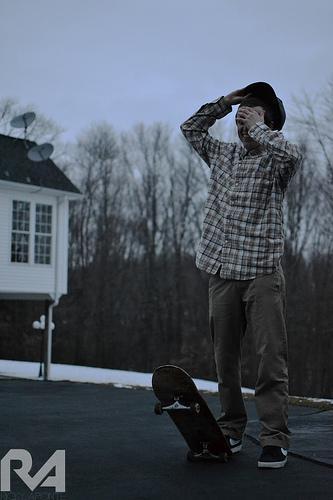How many people are pictured?
Give a very brief answer. 1. 